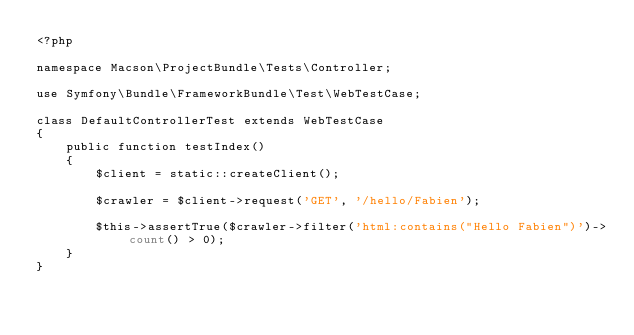<code> <loc_0><loc_0><loc_500><loc_500><_PHP_><?php

namespace Macson\ProjectBundle\Tests\Controller;

use Symfony\Bundle\FrameworkBundle\Test\WebTestCase;

class DefaultControllerTest extends WebTestCase
{
    public function testIndex()
    {
        $client = static::createClient();

        $crawler = $client->request('GET', '/hello/Fabien');

        $this->assertTrue($crawler->filter('html:contains("Hello Fabien")')->count() > 0);
    }
}
</code> 